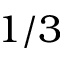<formula> <loc_0><loc_0><loc_500><loc_500>1 / 3</formula> 